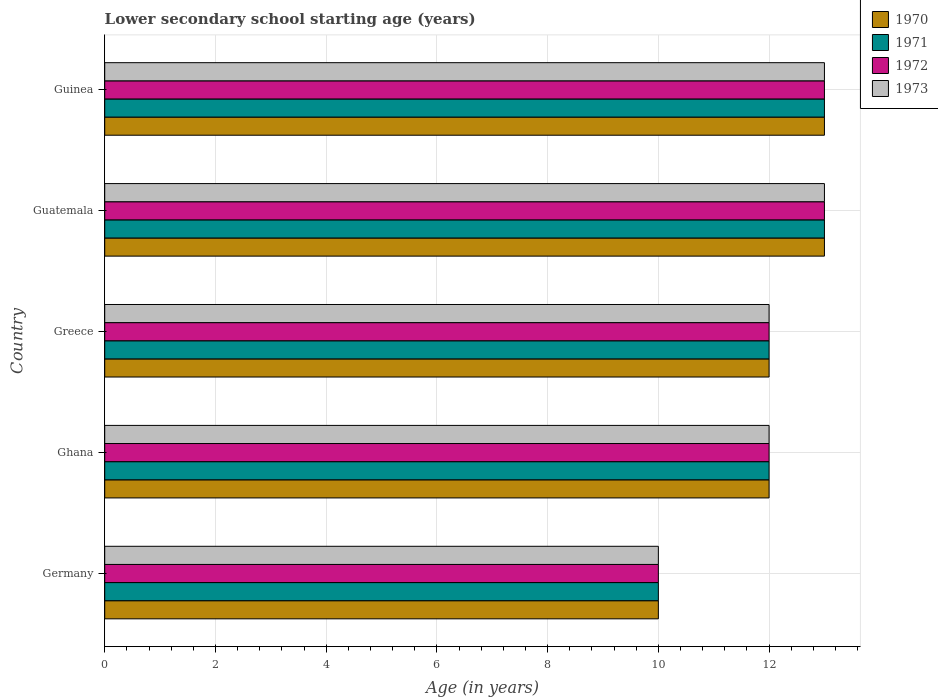Are the number of bars on each tick of the Y-axis equal?
Your response must be concise. Yes. How many bars are there on the 1st tick from the top?
Make the answer very short. 4. What is the label of the 3rd group of bars from the top?
Ensure brevity in your answer.  Greece. In how many cases, is the number of bars for a given country not equal to the number of legend labels?
Ensure brevity in your answer.  0. What is the lower secondary school starting age of children in 1973 in Guinea?
Keep it short and to the point. 13. In which country was the lower secondary school starting age of children in 1972 maximum?
Keep it short and to the point. Guatemala. In which country was the lower secondary school starting age of children in 1972 minimum?
Make the answer very short. Germany. What is the difference between the lower secondary school starting age of children in 1971 in Guatemala and that in Guinea?
Offer a terse response. 0. What is the average lower secondary school starting age of children in 1972 per country?
Give a very brief answer. 12. What is the difference between the lower secondary school starting age of children in 1972 and lower secondary school starting age of children in 1973 in Germany?
Give a very brief answer. 0. In how many countries, is the lower secondary school starting age of children in 1973 greater than 12.4 years?
Keep it short and to the point. 2. What is the ratio of the lower secondary school starting age of children in 1971 in Greece to that in Guatemala?
Your response must be concise. 0.92. Is the lower secondary school starting age of children in 1972 in Germany less than that in Greece?
Offer a very short reply. Yes. Is the difference between the lower secondary school starting age of children in 1972 in Ghana and Greece greater than the difference between the lower secondary school starting age of children in 1973 in Ghana and Greece?
Keep it short and to the point. No. In how many countries, is the lower secondary school starting age of children in 1970 greater than the average lower secondary school starting age of children in 1970 taken over all countries?
Give a very brief answer. 2. Is it the case that in every country, the sum of the lower secondary school starting age of children in 1970 and lower secondary school starting age of children in 1971 is greater than the sum of lower secondary school starting age of children in 1972 and lower secondary school starting age of children in 1973?
Give a very brief answer. No. How many bars are there?
Make the answer very short. 20. Are all the bars in the graph horizontal?
Offer a very short reply. Yes. What is the difference between two consecutive major ticks on the X-axis?
Your answer should be very brief. 2. Are the values on the major ticks of X-axis written in scientific E-notation?
Keep it short and to the point. No. Does the graph contain any zero values?
Ensure brevity in your answer.  No. Does the graph contain grids?
Ensure brevity in your answer.  Yes. Where does the legend appear in the graph?
Offer a terse response. Top right. How many legend labels are there?
Your answer should be very brief. 4. How are the legend labels stacked?
Ensure brevity in your answer.  Vertical. What is the title of the graph?
Give a very brief answer. Lower secondary school starting age (years). Does "2015" appear as one of the legend labels in the graph?
Your answer should be very brief. No. What is the label or title of the X-axis?
Make the answer very short. Age (in years). What is the label or title of the Y-axis?
Your answer should be very brief. Country. What is the Age (in years) in 1970 in Germany?
Provide a short and direct response. 10. What is the Age (in years) in 1971 in Ghana?
Offer a terse response. 12. What is the Age (in years) of 1973 in Ghana?
Make the answer very short. 12. What is the Age (in years) of 1970 in Greece?
Keep it short and to the point. 12. What is the Age (in years) of 1971 in Greece?
Offer a terse response. 12. What is the Age (in years) of 1970 in Guatemala?
Your answer should be compact. 13. What is the Age (in years) of 1971 in Guatemala?
Ensure brevity in your answer.  13. What is the Age (in years) of 1972 in Guatemala?
Your answer should be very brief. 13. What is the Age (in years) in 1973 in Guatemala?
Your answer should be very brief. 13. What is the Age (in years) of 1970 in Guinea?
Your response must be concise. 13. What is the Age (in years) in 1971 in Guinea?
Provide a succinct answer. 13. Across all countries, what is the maximum Age (in years) of 1970?
Make the answer very short. 13. Across all countries, what is the maximum Age (in years) in 1971?
Make the answer very short. 13. Across all countries, what is the maximum Age (in years) of 1972?
Give a very brief answer. 13. Across all countries, what is the maximum Age (in years) of 1973?
Keep it short and to the point. 13. Across all countries, what is the minimum Age (in years) of 1970?
Give a very brief answer. 10. Across all countries, what is the minimum Age (in years) of 1971?
Make the answer very short. 10. Across all countries, what is the minimum Age (in years) in 1973?
Offer a terse response. 10. What is the total Age (in years) in 1970 in the graph?
Your response must be concise. 60. What is the difference between the Age (in years) of 1972 in Germany and that in Ghana?
Give a very brief answer. -2. What is the difference between the Age (in years) of 1973 in Germany and that in Ghana?
Give a very brief answer. -2. What is the difference between the Age (in years) in 1971 in Germany and that in Greece?
Provide a succinct answer. -2. What is the difference between the Age (in years) of 1970 in Germany and that in Guatemala?
Your response must be concise. -3. What is the difference between the Age (in years) in 1971 in Germany and that in Guatemala?
Offer a very short reply. -3. What is the difference between the Age (in years) of 1972 in Germany and that in Guatemala?
Keep it short and to the point. -3. What is the difference between the Age (in years) of 1973 in Germany and that in Guatemala?
Provide a short and direct response. -3. What is the difference between the Age (in years) of 1970 in Germany and that in Guinea?
Your answer should be very brief. -3. What is the difference between the Age (in years) in 1972 in Germany and that in Guinea?
Offer a terse response. -3. What is the difference between the Age (in years) in 1973 in Germany and that in Guinea?
Give a very brief answer. -3. What is the difference between the Age (in years) in 1970 in Ghana and that in Greece?
Your response must be concise. 0. What is the difference between the Age (in years) of 1971 in Ghana and that in Greece?
Your answer should be very brief. 0. What is the difference between the Age (in years) in 1972 in Ghana and that in Greece?
Your response must be concise. 0. What is the difference between the Age (in years) of 1973 in Ghana and that in Greece?
Your answer should be compact. 0. What is the difference between the Age (in years) in 1972 in Ghana and that in Guatemala?
Your answer should be compact. -1. What is the difference between the Age (in years) of 1973 in Ghana and that in Guatemala?
Provide a succinct answer. -1. What is the difference between the Age (in years) of 1971 in Greece and that in Guinea?
Give a very brief answer. -1. What is the difference between the Age (in years) of 1970 in Guatemala and that in Guinea?
Your answer should be very brief. 0. What is the difference between the Age (in years) of 1971 in Guatemala and that in Guinea?
Provide a short and direct response. 0. What is the difference between the Age (in years) of 1972 in Guatemala and that in Guinea?
Provide a short and direct response. 0. What is the difference between the Age (in years) in 1973 in Guatemala and that in Guinea?
Make the answer very short. 0. What is the difference between the Age (in years) of 1970 in Germany and the Age (in years) of 1971 in Ghana?
Keep it short and to the point. -2. What is the difference between the Age (in years) of 1970 in Germany and the Age (in years) of 1972 in Ghana?
Offer a very short reply. -2. What is the difference between the Age (in years) of 1971 in Germany and the Age (in years) of 1972 in Ghana?
Give a very brief answer. -2. What is the difference between the Age (in years) of 1970 in Germany and the Age (in years) of 1972 in Greece?
Give a very brief answer. -2. What is the difference between the Age (in years) in 1970 in Germany and the Age (in years) in 1973 in Greece?
Offer a very short reply. -2. What is the difference between the Age (in years) of 1971 in Germany and the Age (in years) of 1973 in Greece?
Offer a very short reply. -2. What is the difference between the Age (in years) in 1972 in Germany and the Age (in years) in 1973 in Greece?
Give a very brief answer. -2. What is the difference between the Age (in years) of 1970 in Germany and the Age (in years) of 1971 in Guatemala?
Offer a terse response. -3. What is the difference between the Age (in years) of 1971 in Germany and the Age (in years) of 1973 in Guatemala?
Ensure brevity in your answer.  -3. What is the difference between the Age (in years) of 1972 in Germany and the Age (in years) of 1973 in Guatemala?
Your answer should be very brief. -3. What is the difference between the Age (in years) in 1970 in Germany and the Age (in years) in 1971 in Guinea?
Keep it short and to the point. -3. What is the difference between the Age (in years) in 1970 in Germany and the Age (in years) in 1973 in Guinea?
Offer a very short reply. -3. What is the difference between the Age (in years) of 1970 in Ghana and the Age (in years) of 1971 in Greece?
Your answer should be compact. 0. What is the difference between the Age (in years) in 1970 in Ghana and the Age (in years) in 1972 in Greece?
Provide a short and direct response. 0. What is the difference between the Age (in years) in 1971 in Ghana and the Age (in years) in 1972 in Greece?
Provide a succinct answer. 0. What is the difference between the Age (in years) in 1972 in Ghana and the Age (in years) in 1973 in Greece?
Make the answer very short. 0. What is the difference between the Age (in years) in 1970 in Ghana and the Age (in years) in 1971 in Guatemala?
Your answer should be compact. -1. What is the difference between the Age (in years) in 1970 in Ghana and the Age (in years) in 1973 in Guatemala?
Make the answer very short. -1. What is the difference between the Age (in years) of 1970 in Ghana and the Age (in years) of 1971 in Guinea?
Ensure brevity in your answer.  -1. What is the difference between the Age (in years) in 1970 in Ghana and the Age (in years) in 1972 in Guinea?
Keep it short and to the point. -1. What is the difference between the Age (in years) in 1970 in Ghana and the Age (in years) in 1973 in Guinea?
Ensure brevity in your answer.  -1. What is the difference between the Age (in years) in 1971 in Ghana and the Age (in years) in 1972 in Guinea?
Offer a terse response. -1. What is the difference between the Age (in years) in 1971 in Ghana and the Age (in years) in 1973 in Guinea?
Make the answer very short. -1. What is the difference between the Age (in years) in 1970 in Greece and the Age (in years) in 1971 in Guatemala?
Keep it short and to the point. -1. What is the difference between the Age (in years) of 1970 in Greece and the Age (in years) of 1973 in Guatemala?
Offer a very short reply. -1. What is the difference between the Age (in years) of 1971 in Greece and the Age (in years) of 1972 in Guatemala?
Your answer should be compact. -1. What is the difference between the Age (in years) of 1972 in Greece and the Age (in years) of 1973 in Guinea?
Your response must be concise. -1. What is the difference between the Age (in years) in 1970 in Guatemala and the Age (in years) in 1972 in Guinea?
Your answer should be compact. 0. What is the difference between the Age (in years) of 1971 in Guatemala and the Age (in years) of 1972 in Guinea?
Your response must be concise. 0. What is the difference between the Age (in years) in 1971 in Guatemala and the Age (in years) in 1973 in Guinea?
Provide a succinct answer. 0. What is the average Age (in years) of 1970 per country?
Provide a short and direct response. 12. What is the average Age (in years) of 1971 per country?
Offer a very short reply. 12. What is the average Age (in years) in 1972 per country?
Give a very brief answer. 12. What is the average Age (in years) in 1973 per country?
Offer a terse response. 12. What is the difference between the Age (in years) in 1970 and Age (in years) in 1971 in Germany?
Ensure brevity in your answer.  0. What is the difference between the Age (in years) in 1970 and Age (in years) in 1972 in Germany?
Your response must be concise. 0. What is the difference between the Age (in years) of 1970 and Age (in years) of 1973 in Germany?
Your answer should be compact. 0. What is the difference between the Age (in years) in 1971 and Age (in years) in 1972 in Germany?
Provide a short and direct response. 0. What is the difference between the Age (in years) in 1971 and Age (in years) in 1973 in Germany?
Ensure brevity in your answer.  0. What is the difference between the Age (in years) of 1970 and Age (in years) of 1971 in Ghana?
Keep it short and to the point. 0. What is the difference between the Age (in years) of 1970 and Age (in years) of 1972 in Ghana?
Keep it short and to the point. 0. What is the difference between the Age (in years) of 1971 and Age (in years) of 1972 in Ghana?
Your answer should be compact. 0. What is the difference between the Age (in years) in 1971 and Age (in years) in 1973 in Ghana?
Provide a succinct answer. 0. What is the difference between the Age (in years) of 1972 and Age (in years) of 1973 in Ghana?
Your answer should be compact. 0. What is the difference between the Age (in years) of 1971 and Age (in years) of 1972 in Greece?
Keep it short and to the point. 0. What is the difference between the Age (in years) of 1972 and Age (in years) of 1973 in Greece?
Offer a very short reply. 0. What is the difference between the Age (in years) in 1970 and Age (in years) in 1972 in Guatemala?
Provide a short and direct response. 0. What is the difference between the Age (in years) in 1970 and Age (in years) in 1973 in Guatemala?
Provide a short and direct response. 0. What is the difference between the Age (in years) in 1971 and Age (in years) in 1972 in Guatemala?
Keep it short and to the point. 0. What is the difference between the Age (in years) of 1971 and Age (in years) of 1973 in Guatemala?
Provide a short and direct response. 0. What is the difference between the Age (in years) in 1972 and Age (in years) in 1973 in Guatemala?
Make the answer very short. 0. What is the difference between the Age (in years) of 1970 and Age (in years) of 1971 in Guinea?
Provide a succinct answer. 0. What is the difference between the Age (in years) in 1970 and Age (in years) in 1972 in Guinea?
Your answer should be very brief. 0. What is the difference between the Age (in years) of 1970 and Age (in years) of 1973 in Guinea?
Offer a terse response. 0. What is the difference between the Age (in years) in 1972 and Age (in years) in 1973 in Guinea?
Offer a very short reply. 0. What is the ratio of the Age (in years) in 1970 in Germany to that in Ghana?
Ensure brevity in your answer.  0.83. What is the ratio of the Age (in years) of 1971 in Germany to that in Ghana?
Make the answer very short. 0.83. What is the ratio of the Age (in years) in 1972 in Germany to that in Ghana?
Ensure brevity in your answer.  0.83. What is the ratio of the Age (in years) in 1973 in Germany to that in Ghana?
Your answer should be compact. 0.83. What is the ratio of the Age (in years) of 1971 in Germany to that in Greece?
Keep it short and to the point. 0.83. What is the ratio of the Age (in years) in 1973 in Germany to that in Greece?
Give a very brief answer. 0.83. What is the ratio of the Age (in years) in 1970 in Germany to that in Guatemala?
Provide a succinct answer. 0.77. What is the ratio of the Age (in years) in 1971 in Germany to that in Guatemala?
Keep it short and to the point. 0.77. What is the ratio of the Age (in years) in 1972 in Germany to that in Guatemala?
Your answer should be compact. 0.77. What is the ratio of the Age (in years) of 1973 in Germany to that in Guatemala?
Give a very brief answer. 0.77. What is the ratio of the Age (in years) of 1970 in Germany to that in Guinea?
Offer a very short reply. 0.77. What is the ratio of the Age (in years) of 1971 in Germany to that in Guinea?
Ensure brevity in your answer.  0.77. What is the ratio of the Age (in years) of 1972 in Germany to that in Guinea?
Offer a terse response. 0.77. What is the ratio of the Age (in years) of 1973 in Germany to that in Guinea?
Offer a very short reply. 0.77. What is the ratio of the Age (in years) of 1971 in Ghana to that in Greece?
Your answer should be compact. 1. What is the ratio of the Age (in years) of 1972 in Ghana to that in Greece?
Keep it short and to the point. 1. What is the ratio of the Age (in years) of 1970 in Ghana to that in Guatemala?
Give a very brief answer. 0.92. What is the ratio of the Age (in years) in 1971 in Ghana to that in Guatemala?
Your answer should be compact. 0.92. What is the ratio of the Age (in years) in 1972 in Ghana to that in Guatemala?
Provide a short and direct response. 0.92. What is the ratio of the Age (in years) of 1973 in Ghana to that in Guatemala?
Make the answer very short. 0.92. What is the ratio of the Age (in years) of 1971 in Ghana to that in Guinea?
Provide a succinct answer. 0.92. What is the ratio of the Age (in years) of 1972 in Ghana to that in Guinea?
Your answer should be compact. 0.92. What is the ratio of the Age (in years) in 1970 in Greece to that in Guatemala?
Offer a very short reply. 0.92. What is the ratio of the Age (in years) in 1971 in Greece to that in Guatemala?
Offer a very short reply. 0.92. What is the ratio of the Age (in years) in 1971 in Greece to that in Guinea?
Keep it short and to the point. 0.92. What is the ratio of the Age (in years) in 1972 in Greece to that in Guinea?
Offer a terse response. 0.92. What is the ratio of the Age (in years) in 1973 in Greece to that in Guinea?
Your response must be concise. 0.92. What is the ratio of the Age (in years) of 1971 in Guatemala to that in Guinea?
Offer a very short reply. 1. What is the ratio of the Age (in years) of 1972 in Guatemala to that in Guinea?
Offer a terse response. 1. What is the difference between the highest and the second highest Age (in years) of 1970?
Your answer should be very brief. 0. What is the difference between the highest and the second highest Age (in years) of 1971?
Your response must be concise. 0. What is the difference between the highest and the second highest Age (in years) in 1972?
Make the answer very short. 0. What is the difference between the highest and the lowest Age (in years) of 1970?
Provide a short and direct response. 3. What is the difference between the highest and the lowest Age (in years) in 1971?
Ensure brevity in your answer.  3. What is the difference between the highest and the lowest Age (in years) of 1972?
Make the answer very short. 3. 